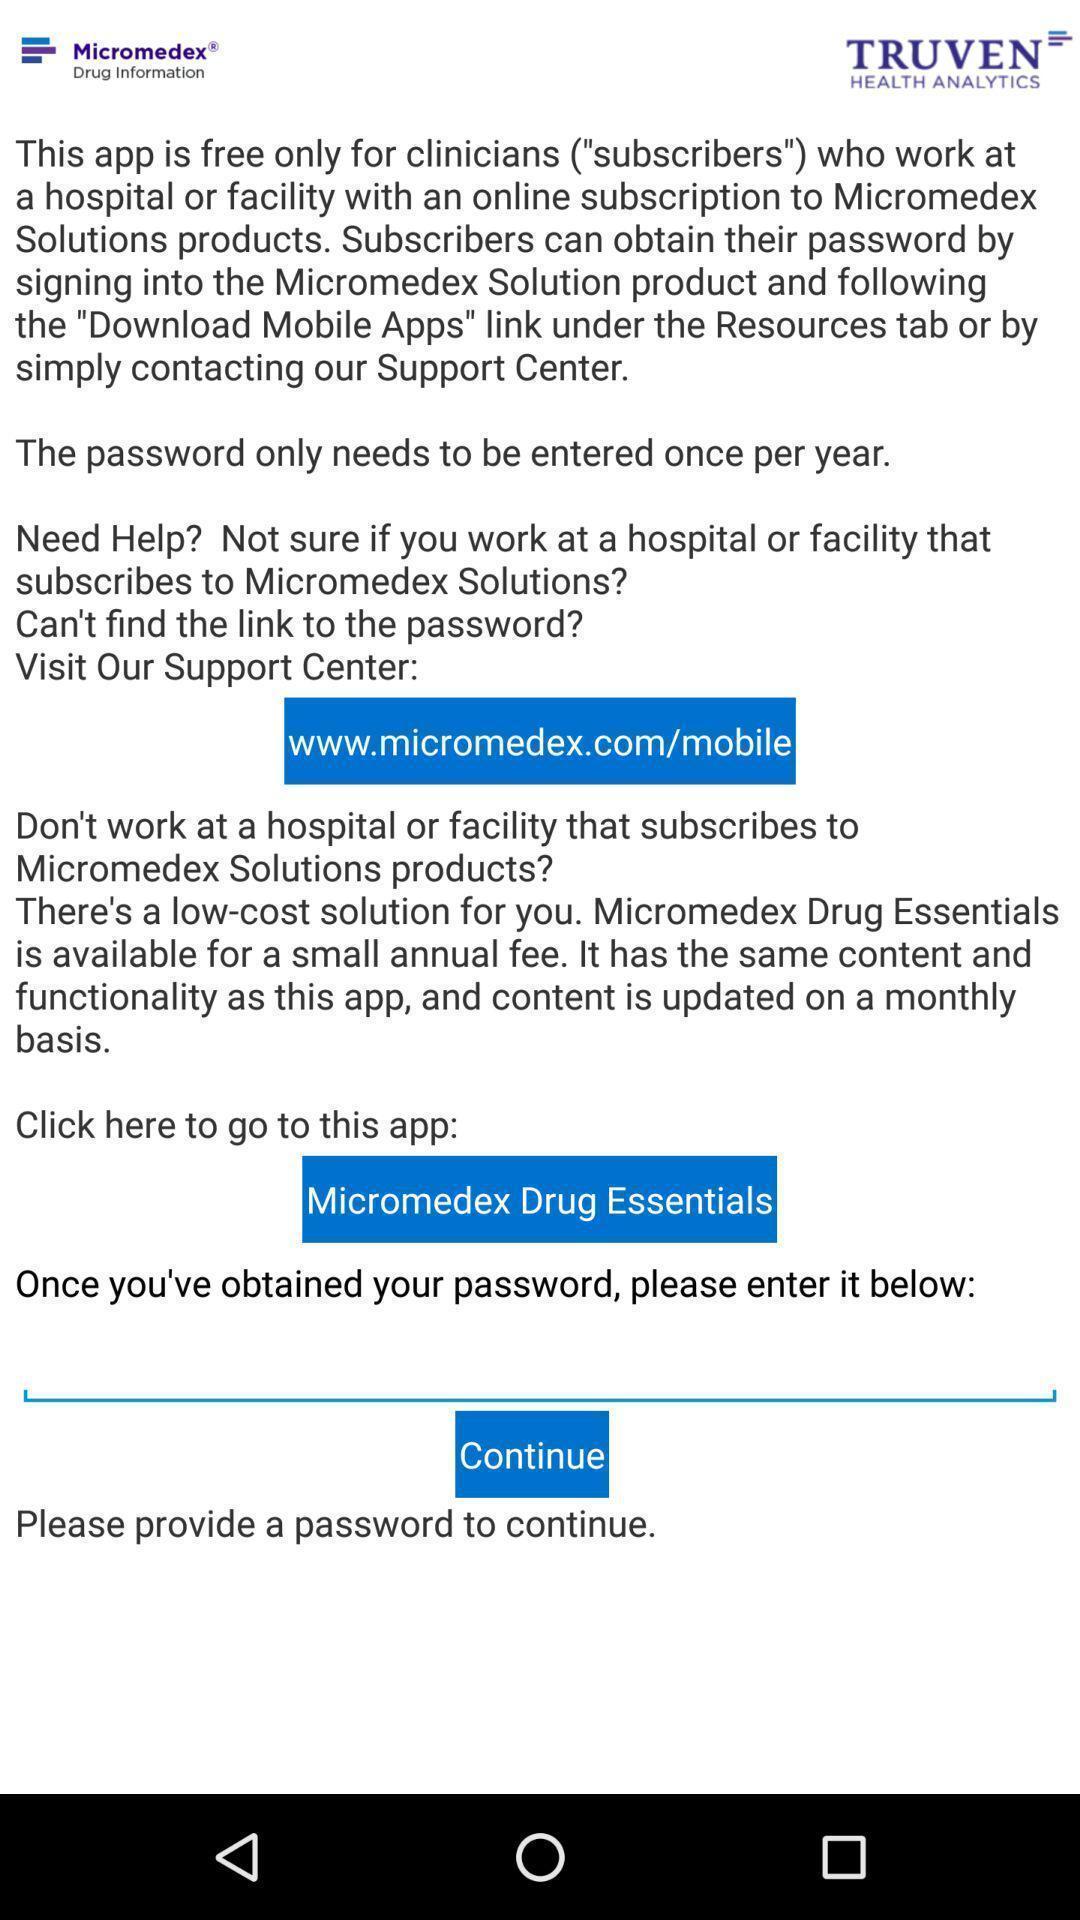What details can you identify in this image? Page displaying the information about social app. 